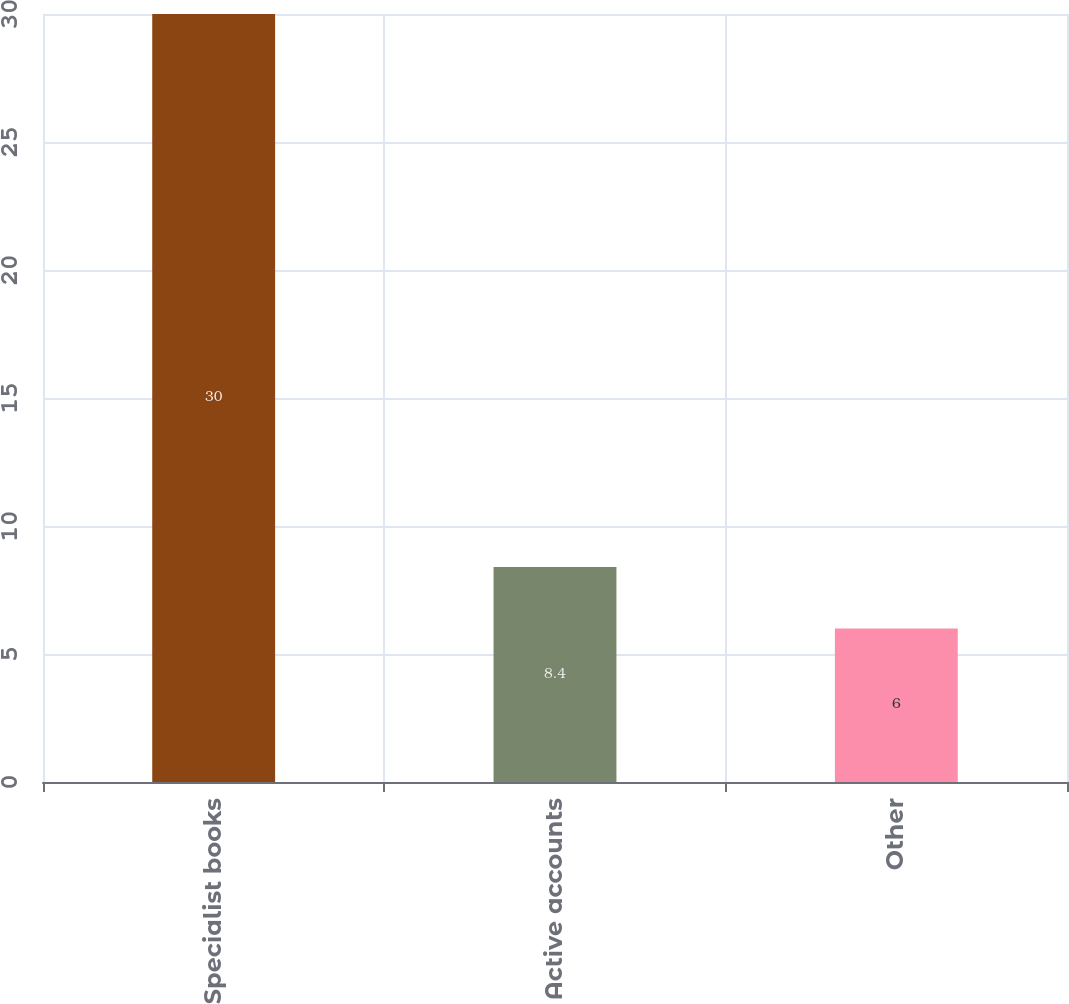<chart> <loc_0><loc_0><loc_500><loc_500><bar_chart><fcel>Specialist books<fcel>Active accounts<fcel>Other<nl><fcel>30<fcel>8.4<fcel>6<nl></chart> 